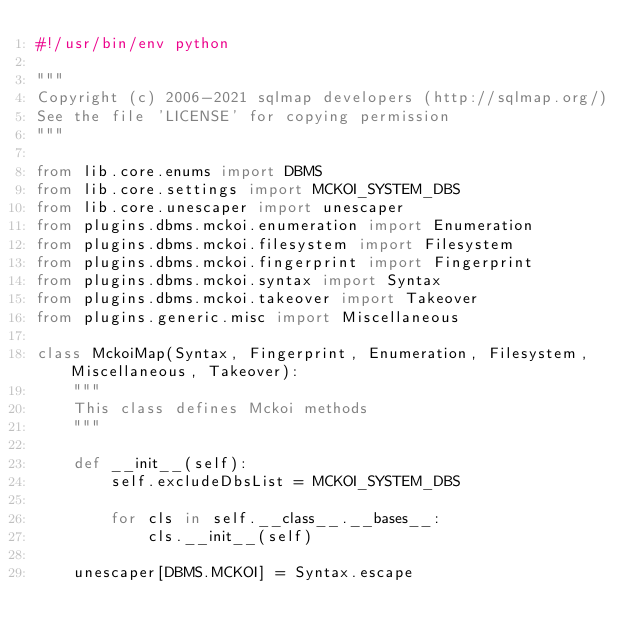<code> <loc_0><loc_0><loc_500><loc_500><_Python_>#!/usr/bin/env python

"""
Copyright (c) 2006-2021 sqlmap developers (http://sqlmap.org/)
See the file 'LICENSE' for copying permission
"""

from lib.core.enums import DBMS
from lib.core.settings import MCKOI_SYSTEM_DBS
from lib.core.unescaper import unescaper
from plugins.dbms.mckoi.enumeration import Enumeration
from plugins.dbms.mckoi.filesystem import Filesystem
from plugins.dbms.mckoi.fingerprint import Fingerprint
from plugins.dbms.mckoi.syntax import Syntax
from plugins.dbms.mckoi.takeover import Takeover
from plugins.generic.misc import Miscellaneous

class MckoiMap(Syntax, Fingerprint, Enumeration, Filesystem, Miscellaneous, Takeover):
    """
    This class defines Mckoi methods
    """

    def __init__(self):
        self.excludeDbsList = MCKOI_SYSTEM_DBS

        for cls in self.__class__.__bases__:
            cls.__init__(self)

    unescaper[DBMS.MCKOI] = Syntax.escape
</code> 